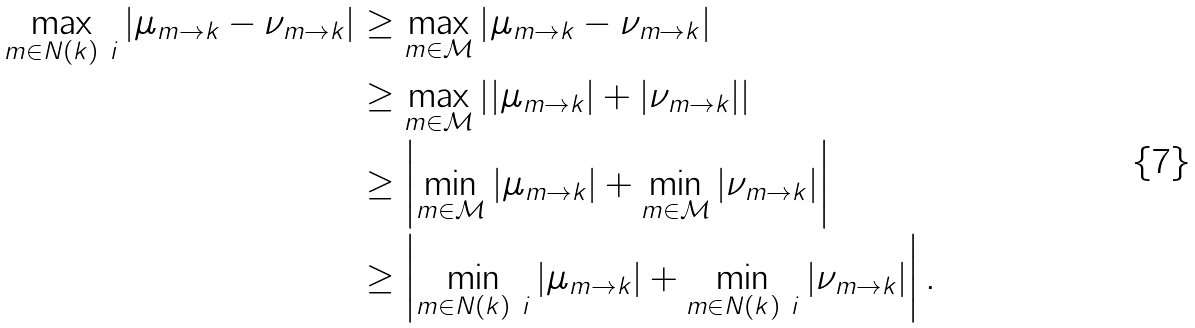<formula> <loc_0><loc_0><loc_500><loc_500>\max _ { m \in N ( k ) \ i } \left | \mu _ { m \rightarrow k } - \nu _ { m \rightarrow k } \right | & \geq \max _ { m \in \mathcal { M } } \left | \mu _ { m \rightarrow k } - \nu _ { m \rightarrow k } \right | \\ & \geq \max _ { m \in \mathcal { M } } \left | | \mu _ { m \rightarrow k } | + | \nu _ { m \rightarrow k } | \right | \\ & \geq \left | \min _ { m \in \mathcal { M } } | \mu _ { m \rightarrow k } | + \min _ { m \in \mathcal { M } } | \nu _ { m \rightarrow k } | \right | \\ & \geq \left | \min _ { m \in N ( k ) \ i } | \mu _ { m \rightarrow k } | + \min _ { m \in N ( k ) \ i } | \nu _ { m \rightarrow k } | \right | .</formula> 